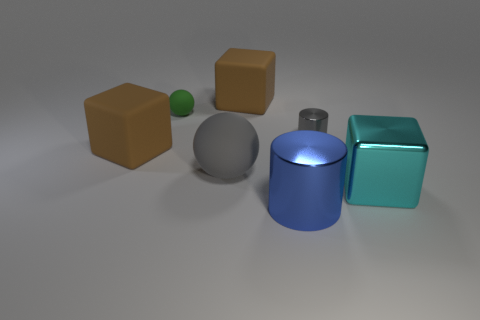Add 1 spheres. How many objects exist? 8 Subtract all cylinders. How many objects are left? 5 Add 6 big metallic cylinders. How many big metallic cylinders exist? 7 Subtract 0 red spheres. How many objects are left? 7 Subtract all large brown shiny objects. Subtract all small gray objects. How many objects are left? 6 Add 4 small green spheres. How many small green spheres are left? 5 